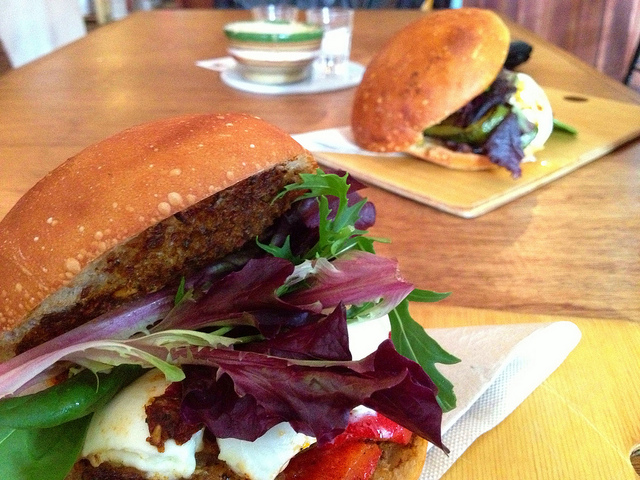Imagine these sandwiches could talk. What story would they tell about their creation? Once upon a time, in a cozy little bistro, two artisan sandwiches were crafted with utmost care and passion. Each ingredient was selected for its quality and flavor. The fresh, crisp lettuce and arugula were picked from a local organic farm. Grilled vegetables, their bodies imbued with the warmth of summer, were carefully layered to build a chorus of flavors. A slice of creamy cheese was added for a rich texture, and the patties, seasoned to perfection, were made by the chef’s secret recipe passed down through generations. All of these were hugged by the warm embrace of golden-brown, toasted buns that were baked to the perfect crunch in the bistro’s very own ovens. As they awaited their departure from the kitchen to the table, the sandwiches shared tales of their journey from the farm to the cozy kitchen, anticipating the moment they would delight the senses of the fortunate diner. What might the chef feel seeing their customers enjoy these sandwiches? The chef’s heart swells with pride and joy each time a customer takes the first bite of these carefully crafted sandwiches. Every nod of approval, every smile of satisfaction, sends a wave of warmth through the chef. The sight of empty plates and lingering conversations over lunch brings an immense sense of fulfillment, as the chef feels deeply connected to each diner through the shared joy of good food. There’s a profound happiness in knowing that the love and care put into every ingredient and step of the sandwich-making process are felt and appreciated by each customer. 